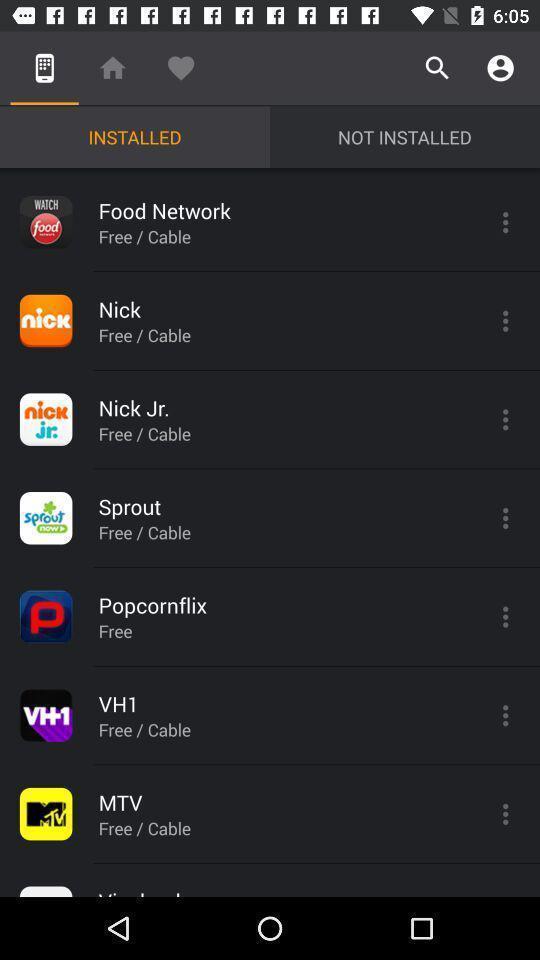What is the overall content of this screenshot? Screen is displaying installed applications. 